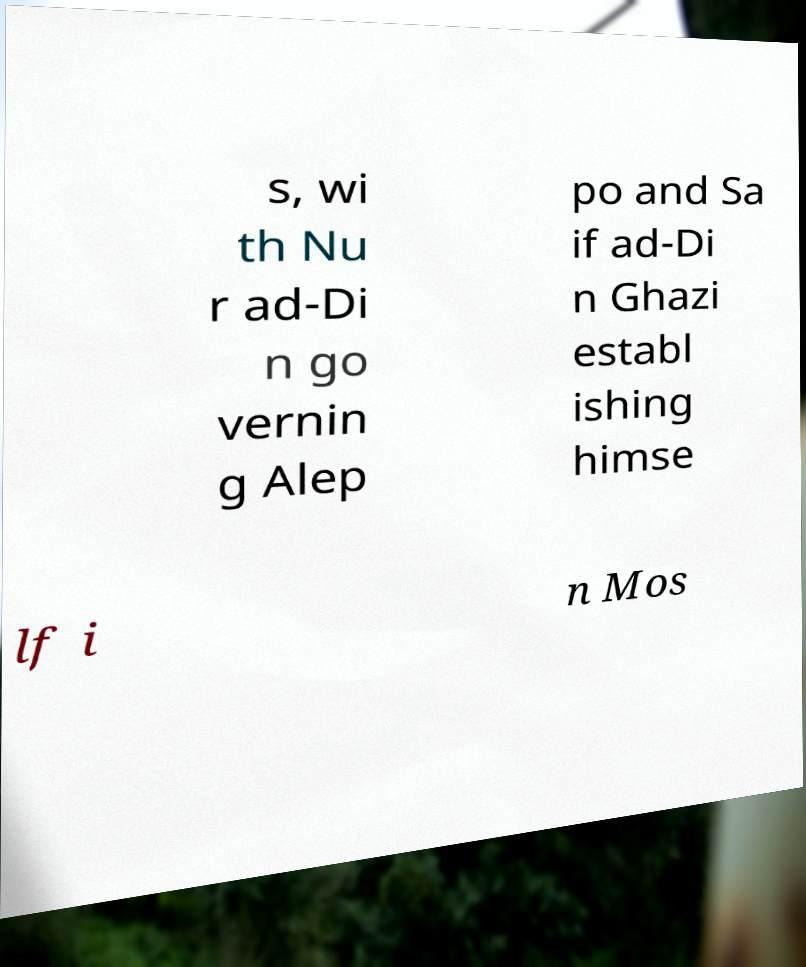Could you extract and type out the text from this image? s, wi th Nu r ad-Di n go vernin g Alep po and Sa if ad-Di n Ghazi establ ishing himse lf i n Mos 